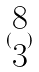<formula> <loc_0><loc_0><loc_500><loc_500>( \begin{matrix} 8 \\ 3 \end{matrix} )</formula> 